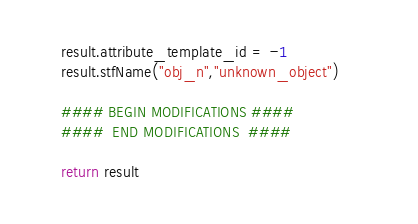<code> <loc_0><loc_0><loc_500><loc_500><_Python_>	result.attribute_template_id = -1
	result.stfName("obj_n","unknown_object")		
	
	#### BEGIN MODIFICATIONS ####
	####  END MODIFICATIONS  ####
	
	return result</code> 